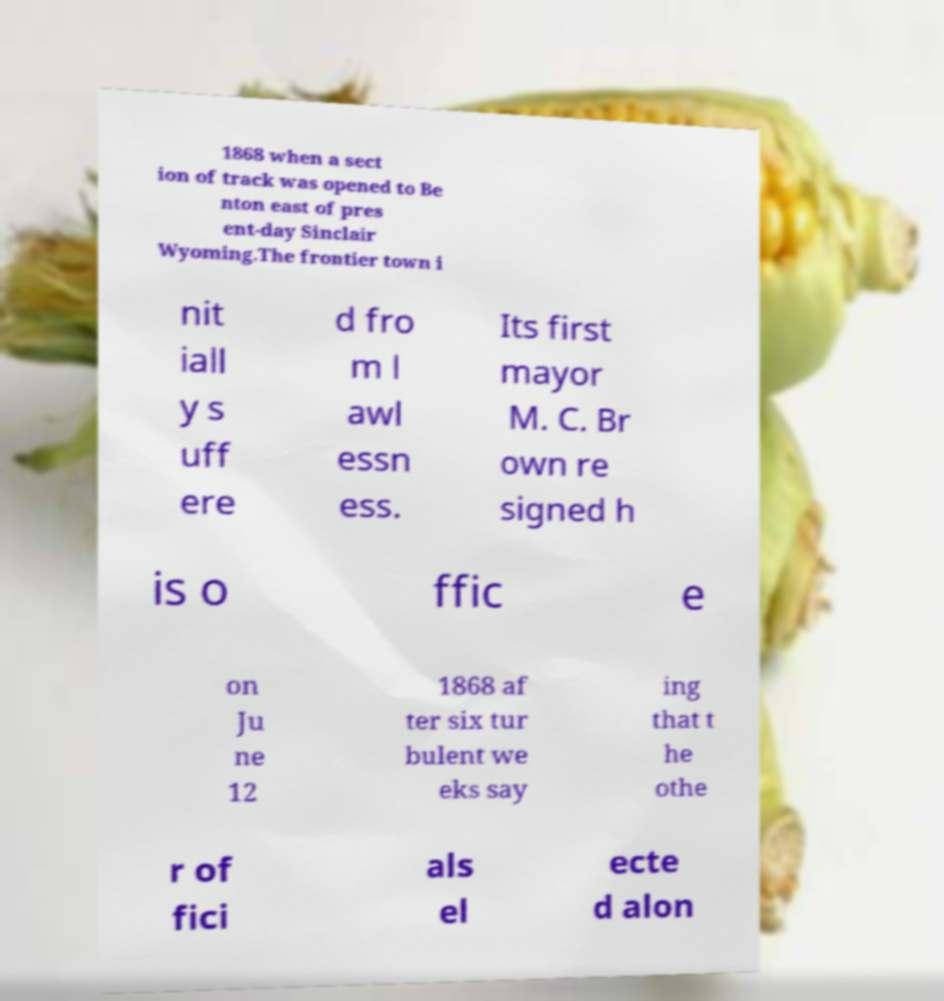Can you read and provide the text displayed in the image?This photo seems to have some interesting text. Can you extract and type it out for me? 1868 when a sect ion of track was opened to Be nton east of pres ent-day Sinclair Wyoming.The frontier town i nit iall y s uff ere d fro m l awl essn ess. Its first mayor M. C. Br own re signed h is o ffic e on Ju ne 12 1868 af ter six tur bulent we eks say ing that t he othe r of fici als el ecte d alon 